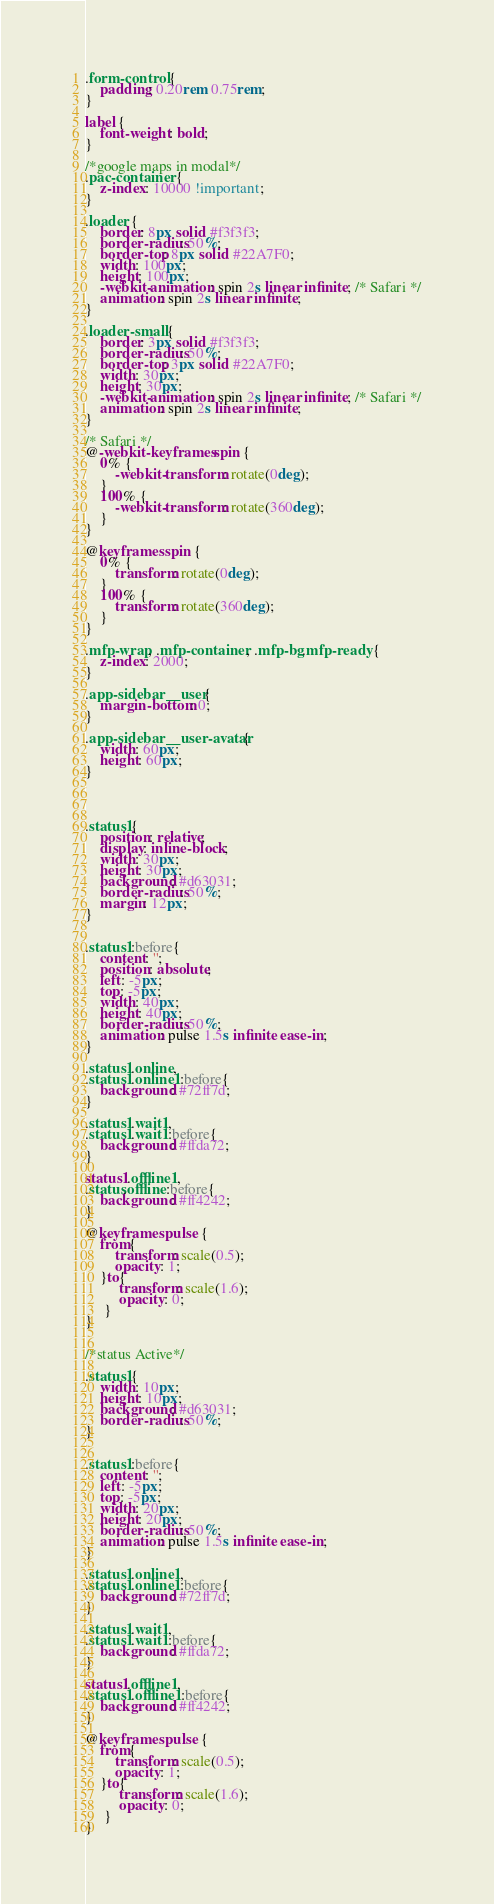<code> <loc_0><loc_0><loc_500><loc_500><_CSS_>.form-control {
    padding: 0.20rem 0.75rem;
}

label {
    font-weight: bold;
}

/*google maps in modal*/
.pac-container {
    z-index: 10000 !important;
}

.loader {
    border: 8px solid #f3f3f3;
    border-radius: 50%;
    border-top: 8px solid #22A7F0;
    width: 100px;
    height: 100px;
    -webkit-animation: spin 2s linear infinite; /* Safari */
    animation: spin 2s linear infinite;
}

.loader-small {
    border: 3px solid #f3f3f3;
    border-radius: 50%;
    border-top: 3px solid #22A7F0;
    width: 30px;
    height: 30px;
    -webkit-animation: spin 2s linear infinite; /* Safari */
    animation: spin 2s linear infinite;
}

/* Safari */
@-webkit-keyframes spin {
    0% {
        -webkit-transform: rotate(0deg);
    }
    100% {
        -webkit-transform: rotate(360deg);
    }
}

@keyframes spin {
    0% {
        transform: rotate(0deg);
    }
    100% {
        transform: rotate(360deg);
    }
}

.mfp-wrap, .mfp-container, .mfp-bg.mfp-ready {
    z-index: 2000;
}

.app-sidebar__user {
    margin-bottom: 0;
}

.app-sidebar__user-avatar {
    width: 60px;
    height: 60px;
}




.status1{
    position: relative;
    display: inline-block;
    width: 30px;
    height: 30px;
    background: #d63031;
    border-radius: 50%;
    margin: 12px;
}


.status1:before{
    content: '';
    position: absolute;
    left: -5px;
    top: -5px;
    width: 40px;
    height: 40px;
    border-radius: 50%;
    animation: pulse 1.5s infinite ease-in;
}

.status1.online,
.status1.online1:before{
    background: #72ff7d;
}

.status1.wait1,
.status1.wait1:before{
    background: #ffda72;
}

status1.offline1,
.status.offline:before{
    background: #ff4242;
}

@keyframes pulse {
    from{
        transform: scale(0.5);
        opacity: 1;
    }to{
         transform: scale(1.6);
         opacity: 0;
     }
}


/*status Active*/

.status1{
    width: 10px;
    height: 10px;
    background: #d63031;
    border-radius: 50%;
}


.status1:before{
    content: '';
    left: -5px;
    top: -5px;
    width: 20px;
    height: 20px;
    border-radius: 50%;
    animation: pulse 1.5s infinite ease-in;
}

.status1.online1,
.status1.online1:before{
    background: #72ff7d;
}

.status1.wait1,
.status1.wait1:before{
    background: #ffda72;
}

status1.offline1,
.status1.offline1:before{
    background: #ff4242;
}

@keyframes pulse {
    from{
        transform: scale(0.5);
        opacity: 1;
    }to{
         transform: scale(1.6);
         opacity: 0;
     }
}

</code> 